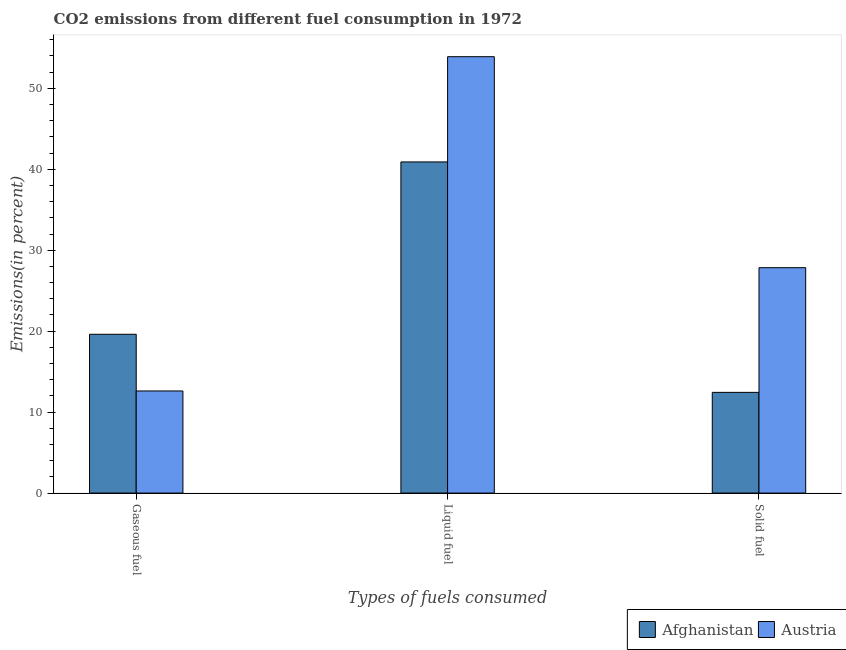How many different coloured bars are there?
Make the answer very short. 2. How many groups of bars are there?
Your answer should be very brief. 3. How many bars are there on the 2nd tick from the right?
Offer a terse response. 2. What is the label of the 2nd group of bars from the left?
Your answer should be compact. Liquid fuel. What is the percentage of solid fuel emission in Austria?
Provide a short and direct response. 27.85. Across all countries, what is the maximum percentage of liquid fuel emission?
Make the answer very short. 53.91. Across all countries, what is the minimum percentage of gaseous fuel emission?
Offer a terse response. 12.61. In which country was the percentage of gaseous fuel emission maximum?
Offer a terse response. Afghanistan. In which country was the percentage of solid fuel emission minimum?
Give a very brief answer. Afghanistan. What is the total percentage of gaseous fuel emission in the graph?
Provide a succinct answer. 32.23. What is the difference between the percentage of liquid fuel emission in Afghanistan and that in Austria?
Your response must be concise. -13. What is the difference between the percentage of liquid fuel emission in Afghanistan and the percentage of gaseous fuel emission in Austria?
Provide a succinct answer. 28.29. What is the average percentage of liquid fuel emission per country?
Offer a very short reply. 47.41. What is the difference between the percentage of liquid fuel emission and percentage of solid fuel emission in Afghanistan?
Ensure brevity in your answer.  28.47. What is the ratio of the percentage of gaseous fuel emission in Afghanistan to that in Austria?
Keep it short and to the point. 1.56. Is the difference between the percentage of solid fuel emission in Austria and Afghanistan greater than the difference between the percentage of liquid fuel emission in Austria and Afghanistan?
Your response must be concise. Yes. What is the difference between the highest and the second highest percentage of gaseous fuel emission?
Your answer should be very brief. 7. What is the difference between the highest and the lowest percentage of solid fuel emission?
Your answer should be very brief. 15.41. What does the 2nd bar from the left in Liquid fuel represents?
Provide a succinct answer. Austria. What does the 1st bar from the right in Gaseous fuel represents?
Offer a terse response. Austria. Is it the case that in every country, the sum of the percentage of gaseous fuel emission and percentage of liquid fuel emission is greater than the percentage of solid fuel emission?
Provide a short and direct response. Yes. How many bars are there?
Make the answer very short. 6. Are all the bars in the graph horizontal?
Ensure brevity in your answer.  No. Where does the legend appear in the graph?
Keep it short and to the point. Bottom right. How many legend labels are there?
Keep it short and to the point. 2. How are the legend labels stacked?
Provide a short and direct response. Horizontal. What is the title of the graph?
Offer a terse response. CO2 emissions from different fuel consumption in 1972. What is the label or title of the X-axis?
Your response must be concise. Types of fuels consumed. What is the label or title of the Y-axis?
Offer a very short reply. Emissions(in percent). What is the Emissions(in percent) in Afghanistan in Gaseous fuel?
Your answer should be compact. 19.62. What is the Emissions(in percent) of Austria in Gaseous fuel?
Your answer should be compact. 12.61. What is the Emissions(in percent) of Afghanistan in Liquid fuel?
Provide a succinct answer. 40.91. What is the Emissions(in percent) in Austria in Liquid fuel?
Give a very brief answer. 53.91. What is the Emissions(in percent) of Afghanistan in Solid fuel?
Your answer should be very brief. 12.44. What is the Emissions(in percent) in Austria in Solid fuel?
Your answer should be very brief. 27.85. Across all Types of fuels consumed, what is the maximum Emissions(in percent) in Afghanistan?
Your response must be concise. 40.91. Across all Types of fuels consumed, what is the maximum Emissions(in percent) of Austria?
Keep it short and to the point. 53.91. Across all Types of fuels consumed, what is the minimum Emissions(in percent) in Afghanistan?
Make the answer very short. 12.44. Across all Types of fuels consumed, what is the minimum Emissions(in percent) in Austria?
Keep it short and to the point. 12.61. What is the total Emissions(in percent) of Afghanistan in the graph?
Keep it short and to the point. 72.97. What is the total Emissions(in percent) in Austria in the graph?
Your answer should be compact. 94.37. What is the difference between the Emissions(in percent) of Afghanistan in Gaseous fuel and that in Liquid fuel?
Your response must be concise. -21.29. What is the difference between the Emissions(in percent) of Austria in Gaseous fuel and that in Liquid fuel?
Ensure brevity in your answer.  -41.29. What is the difference between the Emissions(in percent) in Afghanistan in Gaseous fuel and that in Solid fuel?
Your response must be concise. 7.18. What is the difference between the Emissions(in percent) in Austria in Gaseous fuel and that in Solid fuel?
Give a very brief answer. -15.23. What is the difference between the Emissions(in percent) of Afghanistan in Liquid fuel and that in Solid fuel?
Ensure brevity in your answer.  28.47. What is the difference between the Emissions(in percent) of Austria in Liquid fuel and that in Solid fuel?
Give a very brief answer. 26.06. What is the difference between the Emissions(in percent) of Afghanistan in Gaseous fuel and the Emissions(in percent) of Austria in Liquid fuel?
Provide a succinct answer. -34.29. What is the difference between the Emissions(in percent) in Afghanistan in Gaseous fuel and the Emissions(in percent) in Austria in Solid fuel?
Offer a terse response. -8.23. What is the difference between the Emissions(in percent) of Afghanistan in Liquid fuel and the Emissions(in percent) of Austria in Solid fuel?
Provide a succinct answer. 13.06. What is the average Emissions(in percent) of Afghanistan per Types of fuels consumed?
Make the answer very short. 24.32. What is the average Emissions(in percent) of Austria per Types of fuels consumed?
Offer a very short reply. 31.46. What is the difference between the Emissions(in percent) of Afghanistan and Emissions(in percent) of Austria in Gaseous fuel?
Your response must be concise. 7. What is the difference between the Emissions(in percent) in Afghanistan and Emissions(in percent) in Austria in Liquid fuel?
Keep it short and to the point. -13. What is the difference between the Emissions(in percent) in Afghanistan and Emissions(in percent) in Austria in Solid fuel?
Your answer should be very brief. -15.4. What is the ratio of the Emissions(in percent) in Afghanistan in Gaseous fuel to that in Liquid fuel?
Provide a short and direct response. 0.48. What is the ratio of the Emissions(in percent) of Austria in Gaseous fuel to that in Liquid fuel?
Provide a succinct answer. 0.23. What is the ratio of the Emissions(in percent) in Afghanistan in Gaseous fuel to that in Solid fuel?
Give a very brief answer. 1.58. What is the ratio of the Emissions(in percent) of Austria in Gaseous fuel to that in Solid fuel?
Keep it short and to the point. 0.45. What is the ratio of the Emissions(in percent) in Afghanistan in Liquid fuel to that in Solid fuel?
Offer a very short reply. 3.29. What is the ratio of the Emissions(in percent) in Austria in Liquid fuel to that in Solid fuel?
Give a very brief answer. 1.94. What is the difference between the highest and the second highest Emissions(in percent) in Afghanistan?
Make the answer very short. 21.29. What is the difference between the highest and the second highest Emissions(in percent) of Austria?
Provide a succinct answer. 26.06. What is the difference between the highest and the lowest Emissions(in percent) of Afghanistan?
Offer a very short reply. 28.47. What is the difference between the highest and the lowest Emissions(in percent) of Austria?
Provide a short and direct response. 41.29. 